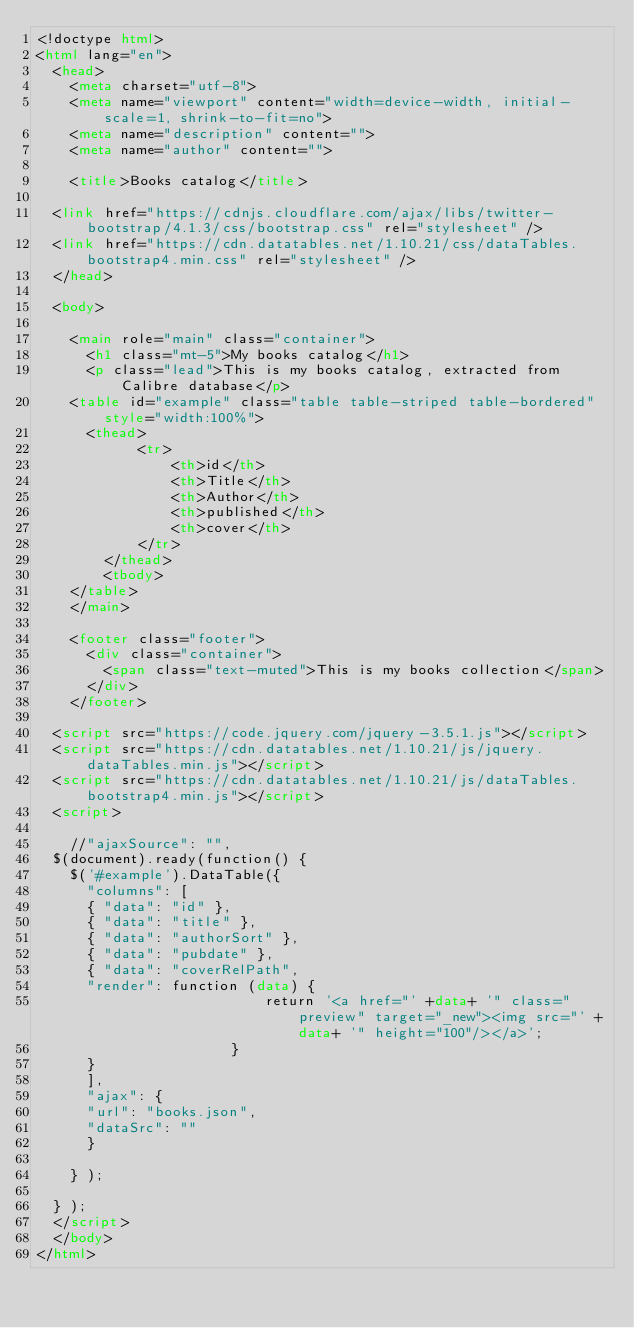<code> <loc_0><loc_0><loc_500><loc_500><_HTML_><!doctype html>
<html lang="en">
  <head>
    <meta charset="utf-8">
    <meta name="viewport" content="width=device-width, initial-scale=1, shrink-to-fit=no">
    <meta name="description" content="">
    <meta name="author" content="">

    <title>Books catalog</title>

	<link href="https://cdnjs.cloudflare.com/ajax/libs/twitter-bootstrap/4.1.3/css/bootstrap.css" rel="stylesheet" />
	<link href="https://cdn.datatables.net/1.10.21/css/dataTables.bootstrap4.min.css" rel="stylesheet" />
  </head>

  <body>

    <main role="main" class="container">
      <h1 class="mt-5">My books catalog</h1>
      <p class="lead">This is my books catalog, extracted from Calibre database</p>
	  <table id="example" class="table table-striped table-bordered" style="width:100%">
	    <thead>
            <tr>
                <th>id</th>
                <th>Title</th>
                <th>Author</th>
                <th>published</th>
                <th>cover</th>
            </tr>
        </thead>
        <tbody>
	  </table>
    </main>

    <footer class="footer">
      <div class="container">
        <span class="text-muted">This is my books collection</span>
      </div>
    </footer>
	
	<script src="https://code.jquery.com/jquery-3.5.1.js"></script>
	<script src="https://cdn.datatables.net/1.10.21/js/jquery.dataTables.min.js"></script>
	<script src="https://cdn.datatables.net/1.10.21/js/dataTables.bootstrap4.min.js"></script>
	<script>
	
		//"ajaxSource": "",
	$(document).ready(function() {
		$('#example').DataTable({
		  "columns": [
			{ "data": "id" },
			{ "data": "title" },
			{ "data": "authorSort" },
			{ "data": "pubdate" },
			{ "data": "coverRelPath",
			"render": function (data) {
                           return '<a href="' +data+ '" class="preview" target="_new"><img src="' +data+ '" height="100"/></a>';
                       }
			}
		  ],
			"ajax": {
			"url": "books.json",
			"dataSrc": ""
			}
			
		} );
		
	} );
	</script>
  </body>
</html>
</code> 